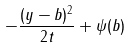<formula> <loc_0><loc_0><loc_500><loc_500>- \frac { ( y - b ) ^ { 2 } } { 2 t } + \psi ( b )</formula> 